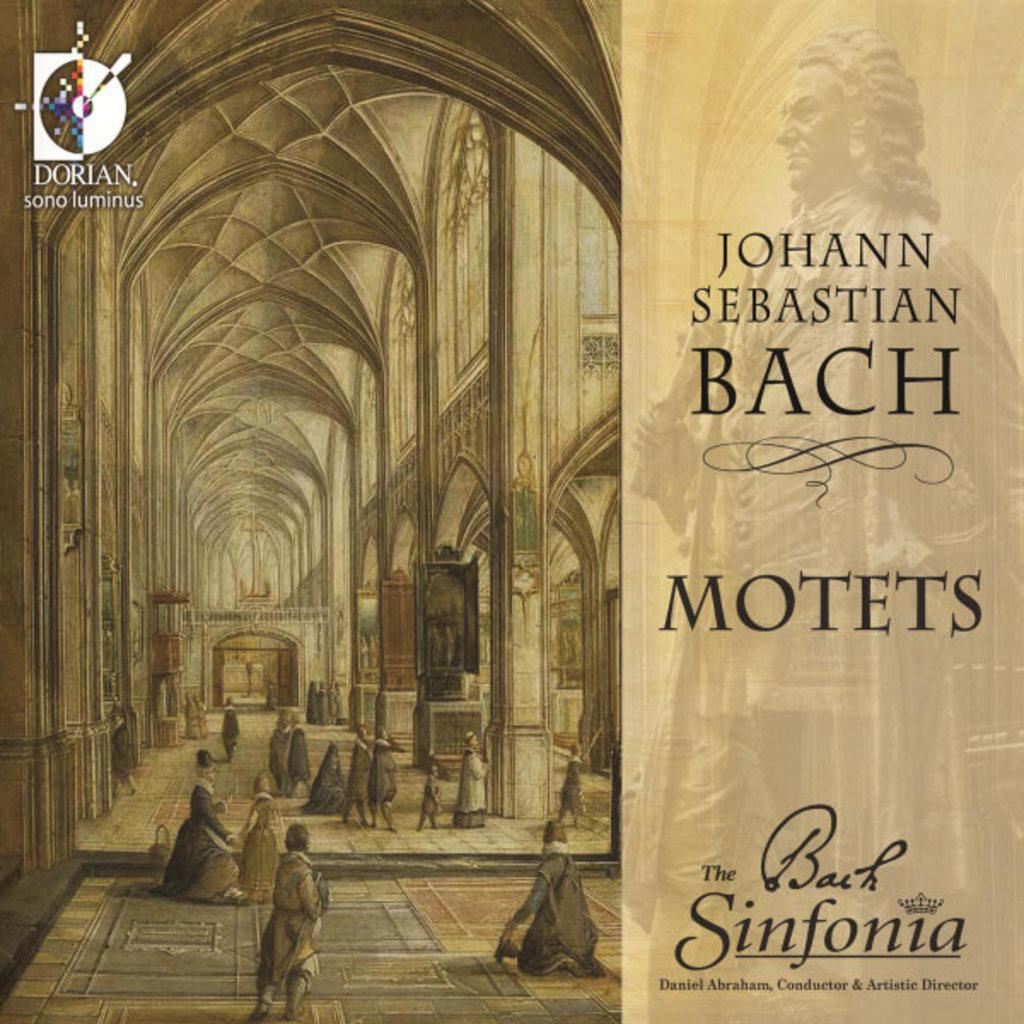<image>
Provide a brief description of the given image. A album cover from Johan Sebastian Bach named Motots 